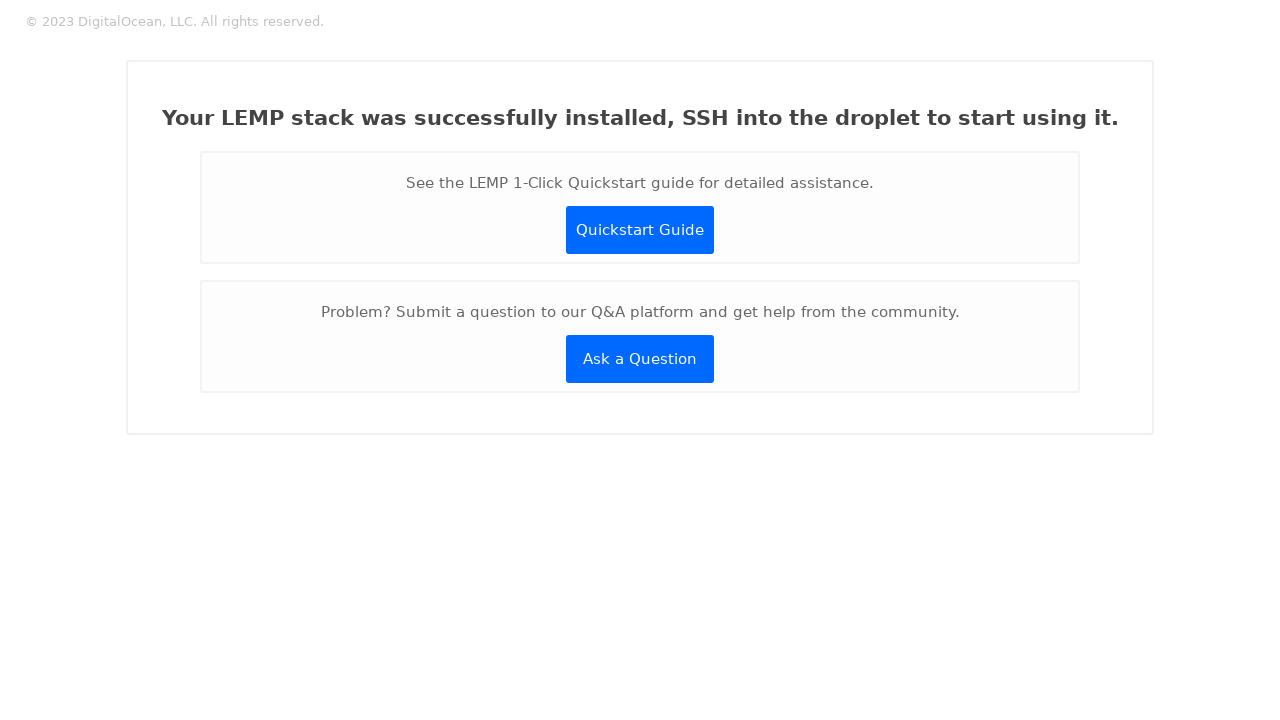What are some security considerations when setting up a webpage like this after installing a LEMP stack? When setting up a webpage after a LEMP stack installation, several security considerations must be addressed. Firstly, ensure that data transmitted to and from the server is encrypted using SSL/TLS to protect against eavesdropping. Implement strict content security policies to prevent XSS attacks. Regularly update all components of your LEMP stack to protect against vulnerabilities. Finally, consider using secure, hashed passwords for any user authentication processes and limit error message details to avoid giving hints to potential attackers. 